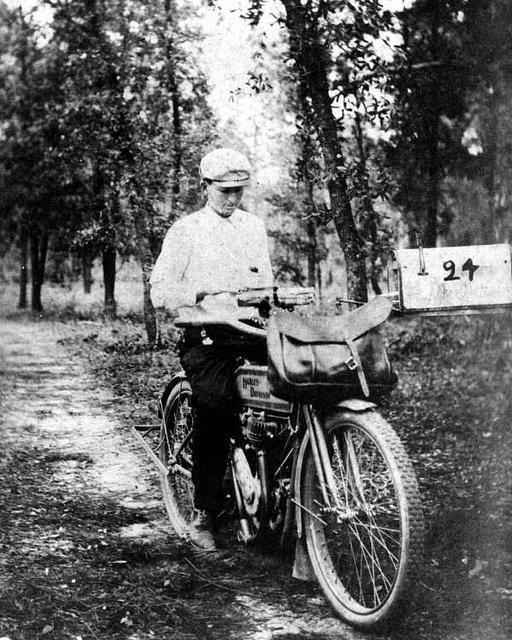How many motorcycles can you see?
Give a very brief answer. 1. How many train cars are painted black?
Give a very brief answer. 0. 